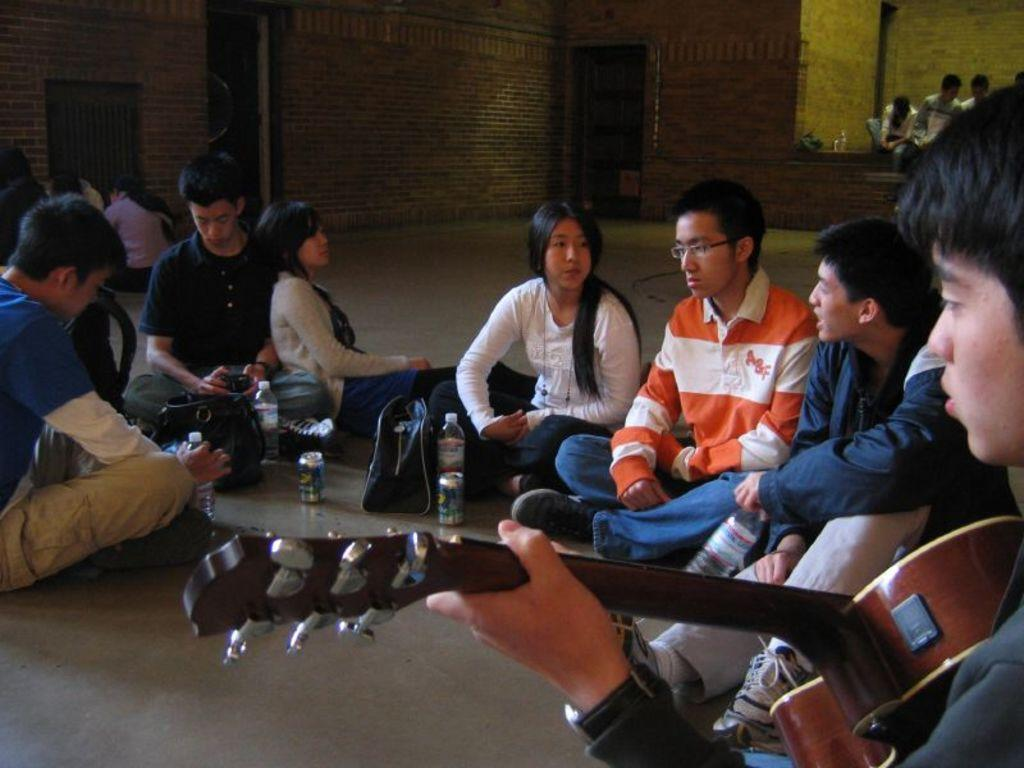What are the people in the image doing? The people in the image are sitting on the ground. Can you describe the boy on the right side of the image? The boy on the right side of the image is holding a guitar. Where is the fire located in the image? There is no fire present in the image. How many boys are holding guitars in the image? There is only one boy holding a guitar in the image. 